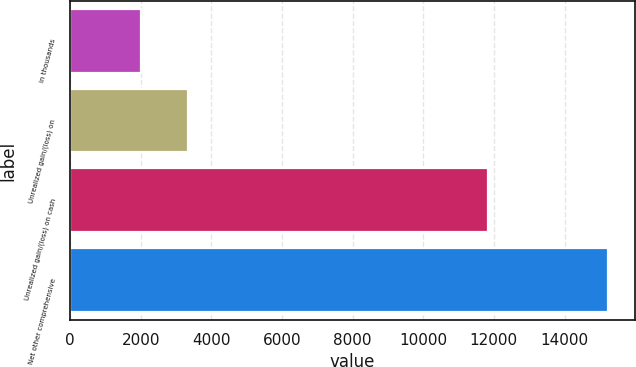Convert chart. <chart><loc_0><loc_0><loc_500><loc_500><bar_chart><fcel>in thousands<fcel>Unrealized gain/(loss) on<fcel>Unrealized gain/(loss) on cash<fcel>Net other comprehensive<nl><fcel>2016<fcel>3337.4<fcel>11833<fcel>15230<nl></chart> 